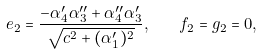<formula> <loc_0><loc_0><loc_500><loc_500>e _ { 2 } = \frac { - \alpha _ { 4 } ^ { \prime } \alpha _ { 3 } ^ { \prime \prime } + \alpha _ { 4 } ^ { \prime \prime } \alpha _ { 3 } ^ { \prime } } { \sqrt { c ^ { 2 } + ( \alpha _ { 1 } ^ { \prime } ) ^ { 2 } } } , \quad f _ { 2 } = g _ { 2 } = 0 ,</formula> 